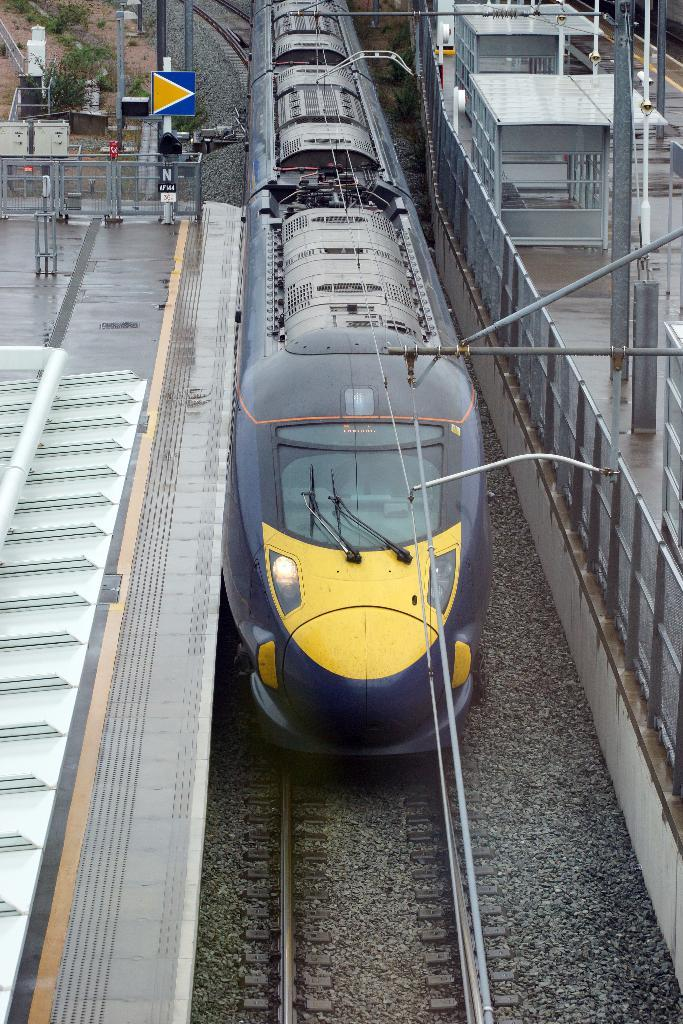What is the main subject of the image? The main subject of the image is a train. What can be observed about the train's position in the image? The train is on tracks in the image. What is located beside the train? There is a fence beside the train. What other structures or objects can be seen in the image? There are poles, a sign board, metal rods, trees, and small rooms visible in the image. How does the train sort the passengers in the image? The train does not sort passengers in the image; it is a static subject. What is the train saying to the passengers as they leave in the image? The train is not depicted as speaking or interacting with passengers in the image. 